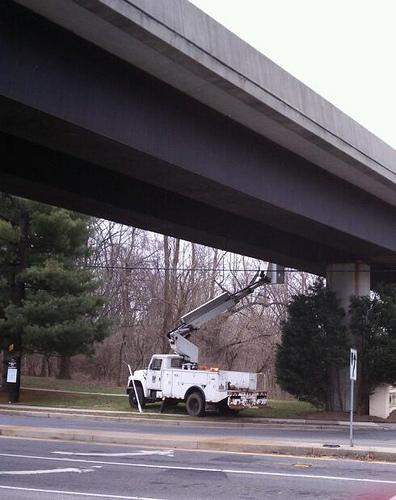What kind of large structure appears in the image, and what is its function? A concrete overpass appears in the image, which serves as a bridge for vehicles or pedestrians to cross above the road. Identify three objects in the image and describe their positions. A concrete overpass is above a road, a white truck with a bucket lift is parked under the overpass, and a green tree is next to the road. Describe the road and any road markings or signs present in the image. A paved city street runs under a concrete overpass, with a long concrete island dividing the road, white turn arrows on the road, and a white and black rectangular traffic sign. What kind of vehicle is parked under the highway, and what is its purpose? A white cherry picker vehicle is parked under the highway, likely used for maintenance work or reaching elevated areas. What is the overall sentiment or mood conveyed by the image? The image conveys a neutral sentiment, as it depicts a typical urban scene with maintenance work under a highway overpass. How many trees are in the image, and what are their different states? There are four trees in the image, including two green trees, a large evergreen tree, and a bare brown tree. Count the number of different types of vehicles and green trees in the image. There is one vehicle and two green trees in the image. Provide a brief description of the scene captured in the image. A white truck with a bucket lift is parked under a concrete overpass, with a green tree and a bare brown tree nearby, and a long concrete island dividing the road. What type of road structure is seen in this image, and which objects are interacting with it? A concrete overpass is seen in the image, with a white truck with bucket lift parked under it and bare brown trees growing beside it. Describe the position and appearance of the signs in the image. A white and black rectangular traffic sign is posted close to the truck, while another white sign is posted on a tree next to the road; both have black arrows pointing upward. Explain the main components and structure of the scene as if it were a diagram. The scene consists of a paved city street, a concrete highway overpass, traffic signs and arrows, work truck with a bucket lift, trees, and road dividers such as a long concrete island and a raised street median. These elements are organized in a way to create a functional urban environment. Design a short story that includes elements from the scene, such as the overpass, the truck, and the trees. In a busy city, a worker with a cherry picker truck is assigned to repair a broken streetlight under a massive concrete overpass. The truck parked under the overpass, and the bucket lift raised to reach the streetlight, had the worker's heart racing, as it was his first time working on such a significant structure. As he worked diligently under the watchful gaze of the green trees lining the street, he couldn't help but feel a sense of accomplishment and pride. Identify and describe the type of road divider present in the scene. There is a long concrete island dividing the road and a raised street median. Have you noticed the red vintage Mustang parked beside the work truck? There is no mention of a red vintage Mustang or any car parked beside the work truck. It adds confusion by specifying the color and brand of the car. Choose the best option to answer the question: What color are the turn arrows painted on the road? a) Yellow b) White c) Red b) White Analyze the emotions or feelings evoked by the landscape and plants in the scene. A mix of urban melancholy and serenity created by the contrast between the concrete structures and the trees and plants. Comment on the current state of the truck's lift. The lift on the truck is raised. Direct your attention to the ice cream vendor pushing a cart along the sidewalk under the bridge. No, it's not mentioned in the image. Illustrate the scene in words as if it were a blueprint for construction. A paved city street runs perpendicular to a concrete highway overpass supported by a column. The street features traffic signs, arrows, and road dividers such as a long concrete island and a raised street median. A work truck with a bucket lift is parked nearby, and trees and plants are strategically placed alongside the road. What activity is happening on the scene involving the work truck? The bucket lift on the truck is raised. Is there a sign on the post next to the power lines? If so, describe it. Yes, there is a white sign posted on the tree. Write an engaging description of the scene. A bustling city street runs under a massive concrete overpass, with traffic signs and arrows guiding drivers. A white truck equipped with a bucket lift is parked on a grassy area, while various trees and plants adorn the sidewalks, creating an atmosphere of urban greenery. Determine the color of the sky in the scene. Cloudy white Try to find a pack of wild horses running across the field at the back of the overpass. There is no mention of any field or wild horses in the annotation. This would lead the person to search for something nonexistent, and it adds extra confusion by including the descriptor "wild." Observe and admire the beautiful sunset depicted in the background sky of the image. A "cloudy white sky" is mentioned, but there is no mention of a sunset. The instruction uses alternative language phrases like "observe" and "admire" to add an artistic element, which may distract from the actual scene. Describe the expression or emotion shown by any person in the image. There are no visible people in the image to describe their expressions. What type of vehicle is parked under the highway overpass? A white truck with a bucket lift Describe the scene using vivid language that evokes emotions. A melancholic ambiance envelops the city as a vast, cold gray concrete overpass casts its looming shadow on the bustling city street below. Trees, both lush and bare, stand silently by the road, as if witnessing the tireless efforts of humanity to create order amidst chaos. Provide a detailed description of the work truck in the image. The work truck is white and equipped with a bucket lift that's currently raised. There is rust on the back of the truck, orange lights, and windows. The front tire of the truck is also visible. Read the text found on the white and black rectangular traffic sign. Unable to read the text clearly from the given information. What is the main purpose of the white arrows painted on the ground? To direct traffic and provide guidance for turns. Don't forget to count the number of purple balloons floating above the city street. There are no details about any balloons, especially purple ones, in the given information. It would divert the user's attention to try finding something that does not exist in the image. Create a poem inspired by the elements present in the scene. Underneath the concrete sky, Can you locate the vibrant graffiti art on the walls of the concrete overpass? There is no mention of any graffiti on the overpass or walls. This instruction complicates the task by including an artistic element that isn't present, so the user will search for something non-existent. 